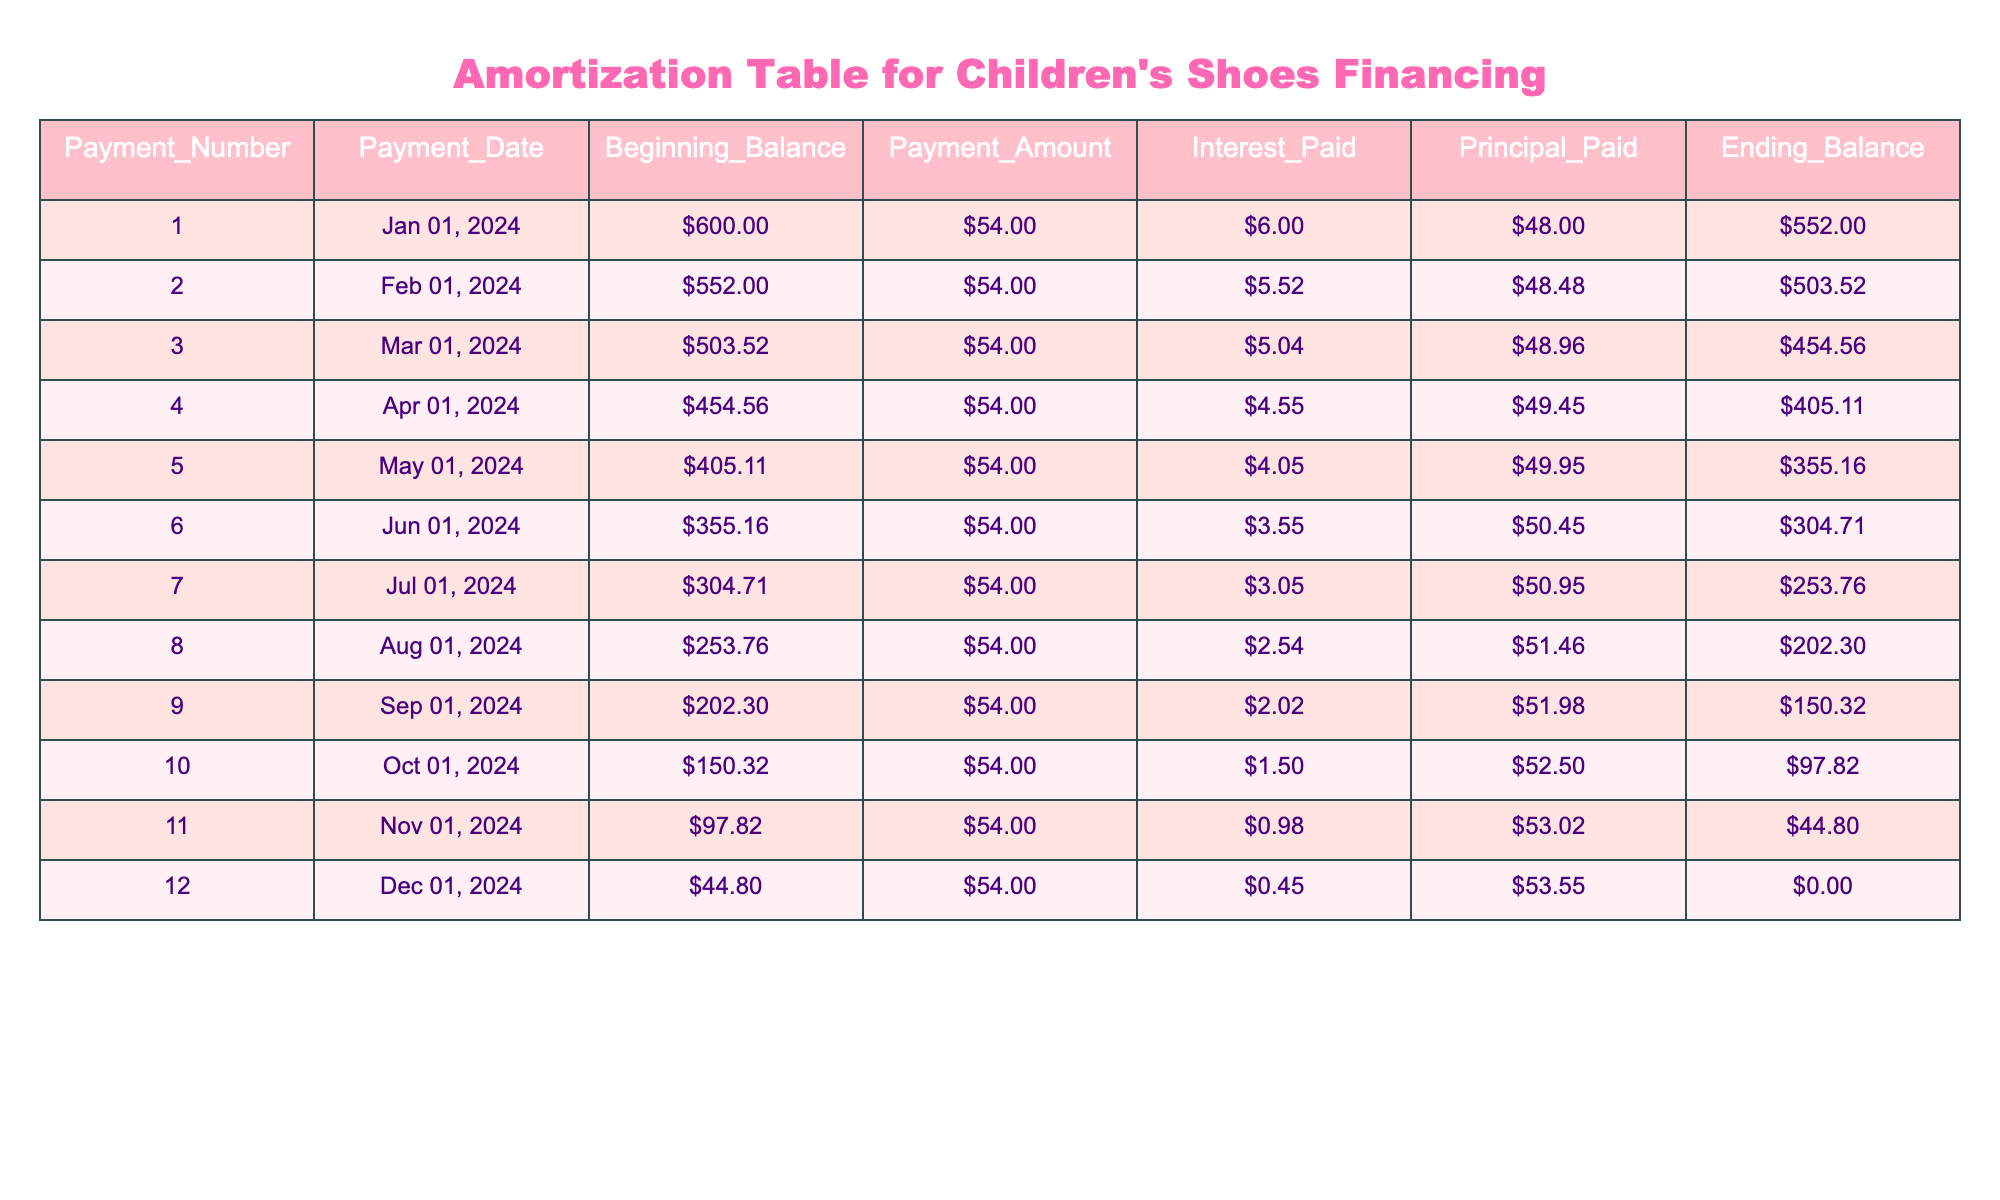What is the beginning balance for the third payment? The beginning balance for the third payment can be found in the third row under the 'Beginning_Balance' column, which is listed as $503.52.
Answer: $503.52 What is the total payment amount over 12 months? The payment amount is constant at $54.00 for each of the 12 months, so we multiply 54 by 12. Therefore, the total amount is 54 * 12 = $648.00.
Answer: $648.00 Did you pay more in principal or interest in the final payment? In the final payment, the interest paid is $0.45, and the principal paid is $53.55. Since $53.55 is greater than $0.45, we paid more in principal.
Answer: Yes What is the average interest paid per payment over the 12 months? To find the average interest paid, sum all the interest payments from each row. The total interest payment is $6.00 + $5.52 + $5.04 + $4.55 + $4.05 + $3.55 + $3.05 + $2.54 + $2.02 + $1.50 + $0.98 + $0.45 = $43.81. Then divide this total by 12, giving an average of about $3.65 per payment.
Answer: $3.65 How much was the principal paid in the sixth payment? The principal paid in the sixth payment can be found in the sixth row under the 'Principal_Paid' column, which is listed as $50.45.
Answer: $50.45 What is the ending balance after the first payment? The ending balance after the first payment is provided in the first row under the 'Ending_Balance' column, which is $552.00.
Answer: $552.00 How much did the ending balance decrease from the first to the last payment? The ending balance after the first payment is $552.00, and after the last payment, it is $0.00. The decrease is calculated as $552.00 - $0.00 = $552.00.
Answer: $552.00 Was the principal paid in the eighth payment higher or lower than $50? In the eighth payment, the principal paid is $51.46, which is higher than $50.
Answer: Higher How much is left to pay after the fifth payment? The ending balance after the fifth payment can be found in the fifth row under the 'Ending_Balance' column, which is $355.16. Therefore, $355.16 is left to pay.
Answer: $355.16 